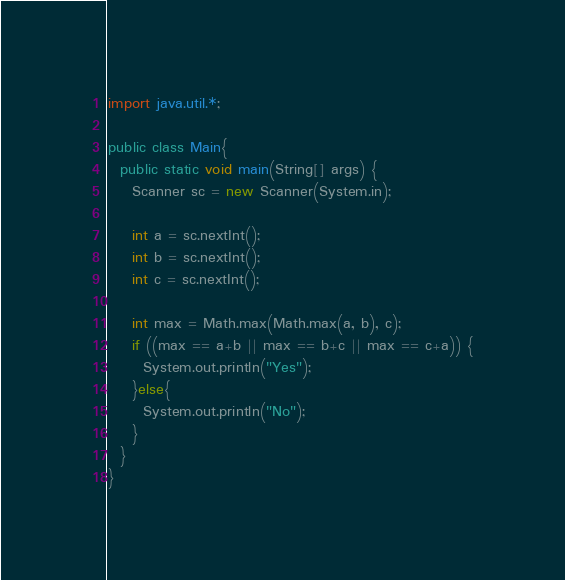Convert code to text. <code><loc_0><loc_0><loc_500><loc_500><_Java_>import java.util.*;

public class Main{
  public static void main(String[] args) {
    Scanner sc = new Scanner(System.in);

    int a = sc.nextInt();
    int b = sc.nextInt();
    int c = sc.nextInt();

    int max = Math.max(Math.max(a, b), c);
    if ((max == a+b || max == b+c || max == c+a)) {
      System.out.println("Yes");
    }else{
      System.out.println("No");
    }
  }
}
</code> 